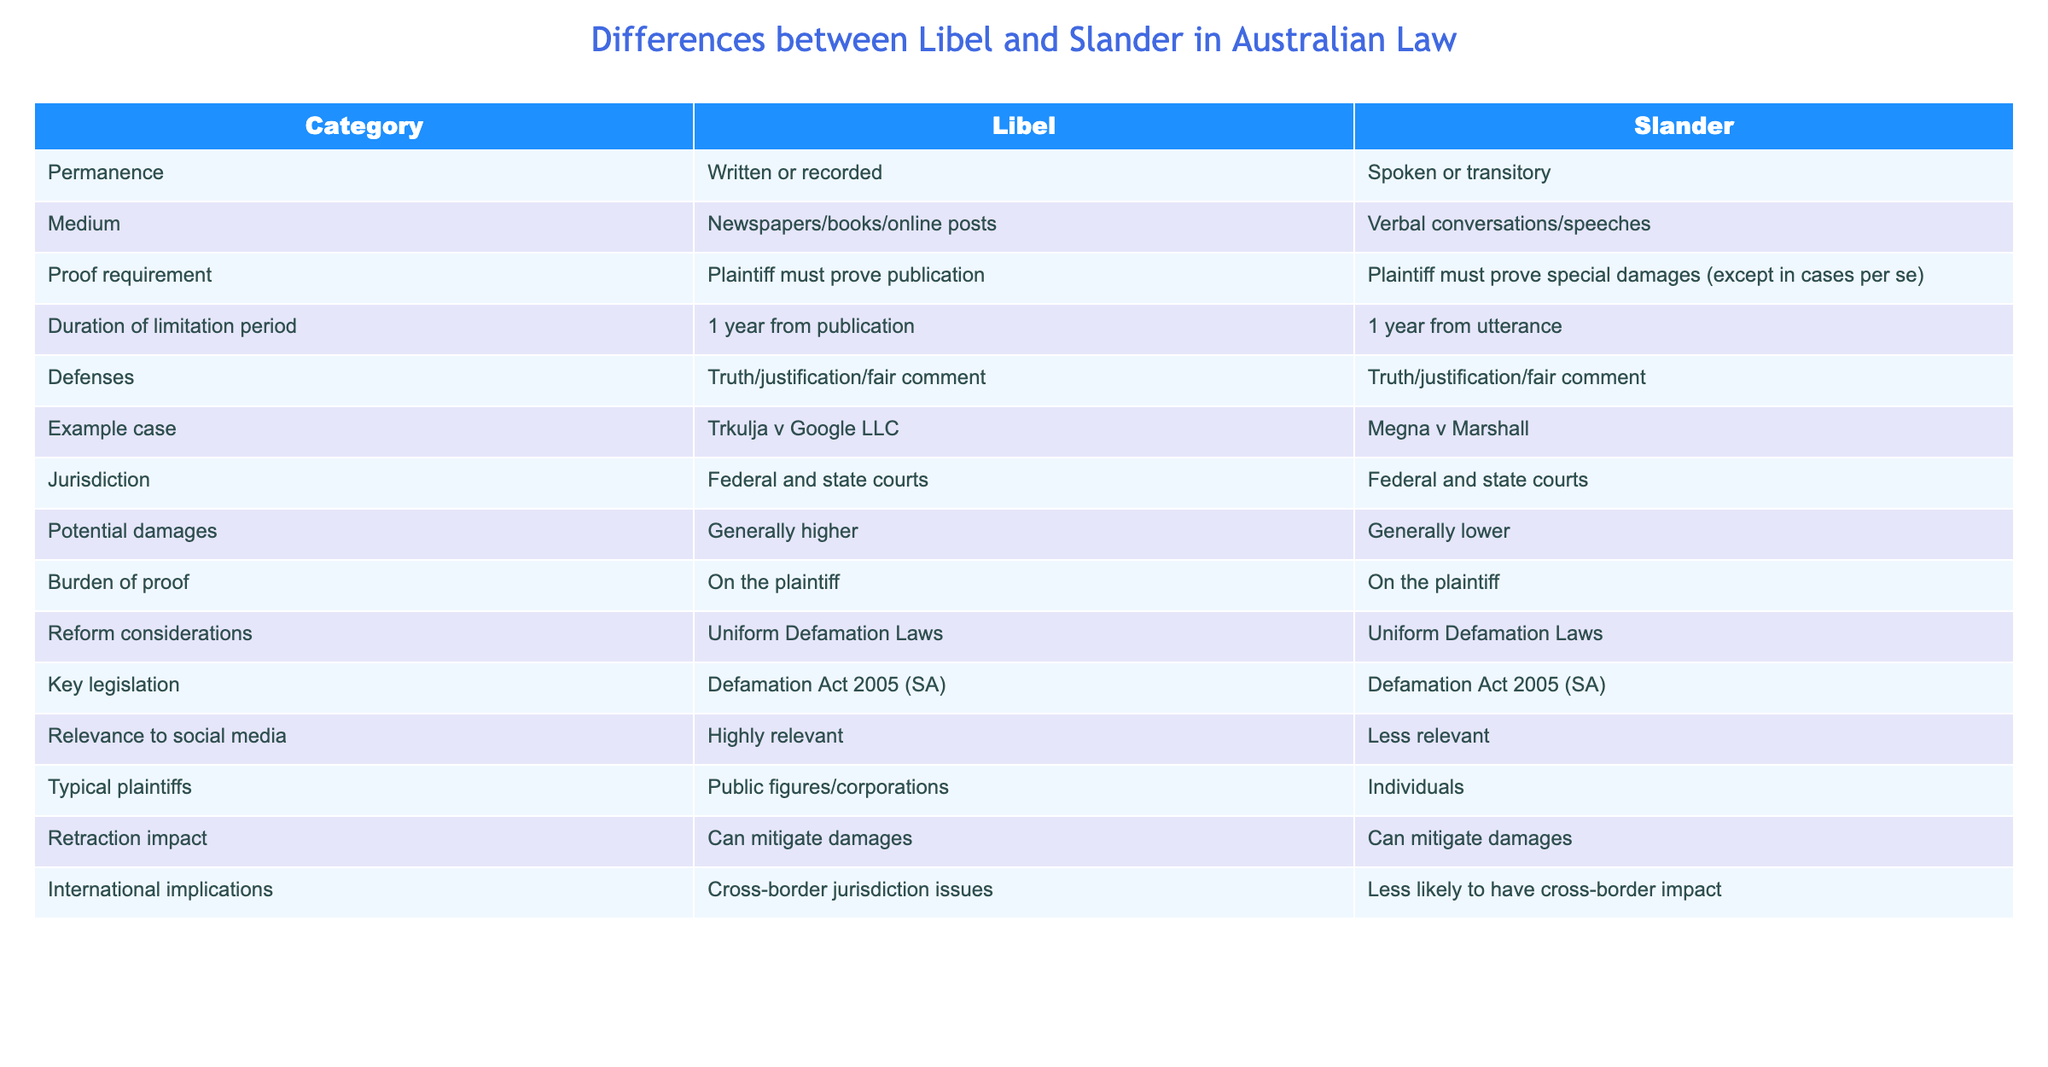What is the key legislation governing both libel and slander in Australia? The table states that both libel and slander are governed by the Defamation Act 2005 (SA). Hence, the key legislation is the same for both categories.
Answer: Defamation Act 2005 (SA) Which category generally has higher potential damages? According to the table, libel generally has higher potential damages than slander, indicating that written or recorded defamation is considered more serious.
Answer: Libel Is the burden of proof on the plaintiff for both libel and slander? The table clearly indicates that the burden of proof is on the plaintiff for both libel and slander, confirming that the responsibility to prove the claim lies with the individual bringing the lawsuit.
Answer: Yes In terms of permanence, how do libel and slander differ? The table specifies that libel is associated with permanence through written or recorded content, while slander is characterized by its spoken or transitory nature, highlighting the fundamental difference in their forms.
Answer: Libel is permanent; slander is transitory What is the duration of the limitation period for both libel and slander claims? The table shows that the duration for both libel and slander claims is one year from the date of publication or utterance, indicating a uniform period for initiating lawsuits.
Answer: 1 year Which category is more relevant to social media? The table indicates that libel is highly relevant to social media, while slander is less relevant, suggesting that written defamation, especially online, poses a greater legal concern.
Answer: Libel What impact does a retraction have on both libel and slander claims? Both libel and slander are mentioned to be potentially mitigated by a retraction, meaning that issuing a retraction could reduce the damages awarded in a defamation case for either type.
Answer: Can mitigate damages for both Why might public figures typically be involved in libel cases rather than slander cases? Given the higher potential damages associated with libel, public figures are more likely to be involved in written defamation cases as they may have more at stake, thus making libel more pertinent to them compared to spoken defamation.
Answer: Libel is more relevant to public figures 